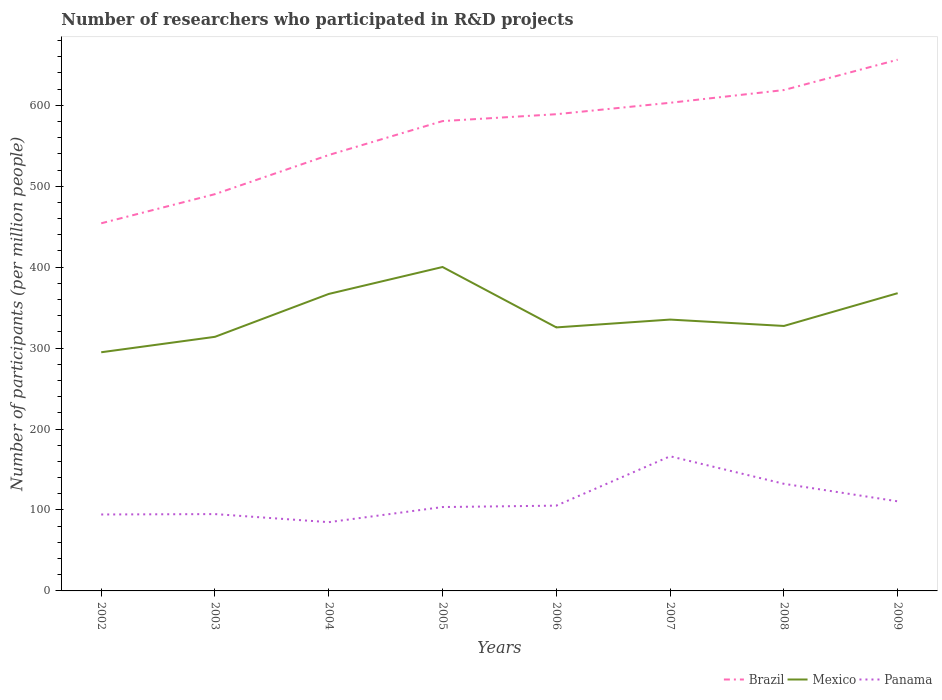How many different coloured lines are there?
Keep it short and to the point. 3. Across all years, what is the maximum number of researchers who participated in R&D projects in Mexico?
Offer a very short reply. 294.87. What is the total number of researchers who participated in R&D projects in Brazil in the graph?
Your answer should be compact. -8.49. What is the difference between the highest and the second highest number of researchers who participated in R&D projects in Mexico?
Offer a very short reply. 105.34. What is the difference between the highest and the lowest number of researchers who participated in R&D projects in Mexico?
Provide a short and direct response. 3. How many lines are there?
Ensure brevity in your answer.  3. How many years are there in the graph?
Keep it short and to the point. 8. What is the difference between two consecutive major ticks on the Y-axis?
Keep it short and to the point. 100. Does the graph contain any zero values?
Provide a succinct answer. No. What is the title of the graph?
Provide a short and direct response. Number of researchers who participated in R&D projects. What is the label or title of the X-axis?
Ensure brevity in your answer.  Years. What is the label or title of the Y-axis?
Your response must be concise. Number of participants (per million people). What is the Number of participants (per million people) of Brazil in 2002?
Provide a succinct answer. 454.21. What is the Number of participants (per million people) of Mexico in 2002?
Provide a succinct answer. 294.87. What is the Number of participants (per million people) of Panama in 2002?
Keep it short and to the point. 94.44. What is the Number of participants (per million people) in Brazil in 2003?
Your response must be concise. 490.22. What is the Number of participants (per million people) of Mexico in 2003?
Provide a short and direct response. 313.95. What is the Number of participants (per million people) of Panama in 2003?
Your answer should be very brief. 94.93. What is the Number of participants (per million people) of Brazil in 2004?
Your response must be concise. 538.58. What is the Number of participants (per million people) in Mexico in 2004?
Your answer should be very brief. 366.94. What is the Number of participants (per million people) in Panama in 2004?
Keep it short and to the point. 84.95. What is the Number of participants (per million people) of Brazil in 2005?
Your response must be concise. 580.49. What is the Number of participants (per million people) of Mexico in 2005?
Provide a short and direct response. 400.21. What is the Number of participants (per million people) in Panama in 2005?
Provide a succinct answer. 103.64. What is the Number of participants (per million people) in Brazil in 2006?
Offer a terse response. 588.98. What is the Number of participants (per million people) in Mexico in 2006?
Make the answer very short. 325.58. What is the Number of participants (per million people) in Panama in 2006?
Provide a short and direct response. 105.37. What is the Number of participants (per million people) in Brazil in 2007?
Keep it short and to the point. 603.11. What is the Number of participants (per million people) in Mexico in 2007?
Your answer should be very brief. 335.25. What is the Number of participants (per million people) of Panama in 2007?
Provide a succinct answer. 166.36. What is the Number of participants (per million people) of Brazil in 2008?
Your response must be concise. 618.83. What is the Number of participants (per million people) of Mexico in 2008?
Provide a short and direct response. 327.37. What is the Number of participants (per million people) in Panama in 2008?
Provide a succinct answer. 132.34. What is the Number of participants (per million people) in Brazil in 2009?
Offer a very short reply. 656.34. What is the Number of participants (per million people) of Mexico in 2009?
Your answer should be very brief. 367.87. What is the Number of participants (per million people) in Panama in 2009?
Provide a short and direct response. 110.69. Across all years, what is the maximum Number of participants (per million people) in Brazil?
Offer a terse response. 656.34. Across all years, what is the maximum Number of participants (per million people) in Mexico?
Ensure brevity in your answer.  400.21. Across all years, what is the maximum Number of participants (per million people) of Panama?
Offer a very short reply. 166.36. Across all years, what is the minimum Number of participants (per million people) of Brazil?
Your answer should be very brief. 454.21. Across all years, what is the minimum Number of participants (per million people) of Mexico?
Ensure brevity in your answer.  294.87. Across all years, what is the minimum Number of participants (per million people) of Panama?
Give a very brief answer. 84.95. What is the total Number of participants (per million people) in Brazil in the graph?
Your answer should be compact. 4530.75. What is the total Number of participants (per million people) in Mexico in the graph?
Your response must be concise. 2732.04. What is the total Number of participants (per million people) in Panama in the graph?
Provide a short and direct response. 892.71. What is the difference between the Number of participants (per million people) in Brazil in 2002 and that in 2003?
Offer a terse response. -36.01. What is the difference between the Number of participants (per million people) in Mexico in 2002 and that in 2003?
Make the answer very short. -19.08. What is the difference between the Number of participants (per million people) in Panama in 2002 and that in 2003?
Offer a very short reply. -0.48. What is the difference between the Number of participants (per million people) in Brazil in 2002 and that in 2004?
Your answer should be compact. -84.37. What is the difference between the Number of participants (per million people) in Mexico in 2002 and that in 2004?
Keep it short and to the point. -72.07. What is the difference between the Number of participants (per million people) of Panama in 2002 and that in 2004?
Provide a short and direct response. 9.49. What is the difference between the Number of participants (per million people) of Brazil in 2002 and that in 2005?
Your answer should be very brief. -126.28. What is the difference between the Number of participants (per million people) of Mexico in 2002 and that in 2005?
Offer a terse response. -105.34. What is the difference between the Number of participants (per million people) of Panama in 2002 and that in 2005?
Your answer should be compact. -9.19. What is the difference between the Number of participants (per million people) of Brazil in 2002 and that in 2006?
Ensure brevity in your answer.  -134.77. What is the difference between the Number of participants (per million people) of Mexico in 2002 and that in 2006?
Your answer should be very brief. -30.71. What is the difference between the Number of participants (per million people) in Panama in 2002 and that in 2006?
Your answer should be compact. -10.93. What is the difference between the Number of participants (per million people) of Brazil in 2002 and that in 2007?
Your answer should be very brief. -148.9. What is the difference between the Number of participants (per million people) of Mexico in 2002 and that in 2007?
Your response must be concise. -40.38. What is the difference between the Number of participants (per million people) of Panama in 2002 and that in 2007?
Ensure brevity in your answer.  -71.91. What is the difference between the Number of participants (per million people) in Brazil in 2002 and that in 2008?
Give a very brief answer. -164.62. What is the difference between the Number of participants (per million people) of Mexico in 2002 and that in 2008?
Provide a succinct answer. -32.5. What is the difference between the Number of participants (per million people) in Panama in 2002 and that in 2008?
Offer a very short reply. -37.89. What is the difference between the Number of participants (per million people) of Brazil in 2002 and that in 2009?
Ensure brevity in your answer.  -202.12. What is the difference between the Number of participants (per million people) of Mexico in 2002 and that in 2009?
Provide a succinct answer. -73. What is the difference between the Number of participants (per million people) in Panama in 2002 and that in 2009?
Keep it short and to the point. -16.25. What is the difference between the Number of participants (per million people) in Brazil in 2003 and that in 2004?
Keep it short and to the point. -48.36. What is the difference between the Number of participants (per million people) in Mexico in 2003 and that in 2004?
Provide a succinct answer. -52.99. What is the difference between the Number of participants (per million people) of Panama in 2003 and that in 2004?
Make the answer very short. 9.97. What is the difference between the Number of participants (per million people) in Brazil in 2003 and that in 2005?
Offer a very short reply. -90.27. What is the difference between the Number of participants (per million people) in Mexico in 2003 and that in 2005?
Provide a short and direct response. -86.25. What is the difference between the Number of participants (per million people) in Panama in 2003 and that in 2005?
Your answer should be compact. -8.71. What is the difference between the Number of participants (per million people) in Brazil in 2003 and that in 2006?
Offer a terse response. -98.76. What is the difference between the Number of participants (per million people) of Mexico in 2003 and that in 2006?
Your answer should be very brief. -11.63. What is the difference between the Number of participants (per million people) in Panama in 2003 and that in 2006?
Offer a terse response. -10.44. What is the difference between the Number of participants (per million people) in Brazil in 2003 and that in 2007?
Give a very brief answer. -112.89. What is the difference between the Number of participants (per million people) of Mexico in 2003 and that in 2007?
Provide a short and direct response. -21.3. What is the difference between the Number of participants (per million people) in Panama in 2003 and that in 2007?
Keep it short and to the point. -71.43. What is the difference between the Number of participants (per million people) in Brazil in 2003 and that in 2008?
Give a very brief answer. -128.61. What is the difference between the Number of participants (per million people) in Mexico in 2003 and that in 2008?
Ensure brevity in your answer.  -13.42. What is the difference between the Number of participants (per million people) of Panama in 2003 and that in 2008?
Offer a terse response. -37.41. What is the difference between the Number of participants (per million people) in Brazil in 2003 and that in 2009?
Offer a terse response. -166.11. What is the difference between the Number of participants (per million people) of Mexico in 2003 and that in 2009?
Provide a short and direct response. -53.91. What is the difference between the Number of participants (per million people) in Panama in 2003 and that in 2009?
Give a very brief answer. -15.77. What is the difference between the Number of participants (per million people) in Brazil in 2004 and that in 2005?
Keep it short and to the point. -41.91. What is the difference between the Number of participants (per million people) of Mexico in 2004 and that in 2005?
Provide a succinct answer. -33.27. What is the difference between the Number of participants (per million people) in Panama in 2004 and that in 2005?
Your response must be concise. -18.68. What is the difference between the Number of participants (per million people) in Brazil in 2004 and that in 2006?
Your response must be concise. -50.41. What is the difference between the Number of participants (per million people) in Mexico in 2004 and that in 2006?
Make the answer very short. 41.36. What is the difference between the Number of participants (per million people) of Panama in 2004 and that in 2006?
Offer a terse response. -20.42. What is the difference between the Number of participants (per million people) in Brazil in 2004 and that in 2007?
Give a very brief answer. -64.53. What is the difference between the Number of participants (per million people) of Mexico in 2004 and that in 2007?
Give a very brief answer. 31.69. What is the difference between the Number of participants (per million people) of Panama in 2004 and that in 2007?
Keep it short and to the point. -81.4. What is the difference between the Number of participants (per million people) of Brazil in 2004 and that in 2008?
Your response must be concise. -80.25. What is the difference between the Number of participants (per million people) in Mexico in 2004 and that in 2008?
Give a very brief answer. 39.57. What is the difference between the Number of participants (per million people) of Panama in 2004 and that in 2008?
Keep it short and to the point. -47.38. What is the difference between the Number of participants (per million people) of Brazil in 2004 and that in 2009?
Ensure brevity in your answer.  -117.76. What is the difference between the Number of participants (per million people) in Mexico in 2004 and that in 2009?
Provide a short and direct response. -0.93. What is the difference between the Number of participants (per million people) of Panama in 2004 and that in 2009?
Provide a succinct answer. -25.74. What is the difference between the Number of participants (per million people) in Brazil in 2005 and that in 2006?
Provide a short and direct response. -8.49. What is the difference between the Number of participants (per million people) of Mexico in 2005 and that in 2006?
Give a very brief answer. 74.63. What is the difference between the Number of participants (per million people) in Panama in 2005 and that in 2006?
Your answer should be compact. -1.73. What is the difference between the Number of participants (per million people) in Brazil in 2005 and that in 2007?
Offer a terse response. -22.62. What is the difference between the Number of participants (per million people) of Mexico in 2005 and that in 2007?
Provide a short and direct response. 64.96. What is the difference between the Number of participants (per million people) of Panama in 2005 and that in 2007?
Give a very brief answer. -62.72. What is the difference between the Number of participants (per million people) of Brazil in 2005 and that in 2008?
Your response must be concise. -38.34. What is the difference between the Number of participants (per million people) of Mexico in 2005 and that in 2008?
Make the answer very short. 72.84. What is the difference between the Number of participants (per million people) in Panama in 2005 and that in 2008?
Offer a very short reply. -28.7. What is the difference between the Number of participants (per million people) in Brazil in 2005 and that in 2009?
Your response must be concise. -75.85. What is the difference between the Number of participants (per million people) of Mexico in 2005 and that in 2009?
Offer a very short reply. 32.34. What is the difference between the Number of participants (per million people) in Panama in 2005 and that in 2009?
Your response must be concise. -7.06. What is the difference between the Number of participants (per million people) of Brazil in 2006 and that in 2007?
Keep it short and to the point. -14.13. What is the difference between the Number of participants (per million people) of Mexico in 2006 and that in 2007?
Offer a very short reply. -9.67. What is the difference between the Number of participants (per million people) in Panama in 2006 and that in 2007?
Offer a very short reply. -60.99. What is the difference between the Number of participants (per million people) in Brazil in 2006 and that in 2008?
Your answer should be compact. -29.85. What is the difference between the Number of participants (per million people) in Mexico in 2006 and that in 2008?
Offer a terse response. -1.79. What is the difference between the Number of participants (per million people) of Panama in 2006 and that in 2008?
Offer a terse response. -26.97. What is the difference between the Number of participants (per million people) in Brazil in 2006 and that in 2009?
Make the answer very short. -67.35. What is the difference between the Number of participants (per million people) of Mexico in 2006 and that in 2009?
Provide a short and direct response. -42.29. What is the difference between the Number of participants (per million people) in Panama in 2006 and that in 2009?
Offer a terse response. -5.32. What is the difference between the Number of participants (per million people) in Brazil in 2007 and that in 2008?
Make the answer very short. -15.72. What is the difference between the Number of participants (per million people) of Mexico in 2007 and that in 2008?
Offer a very short reply. 7.88. What is the difference between the Number of participants (per million people) of Panama in 2007 and that in 2008?
Provide a short and direct response. 34.02. What is the difference between the Number of participants (per million people) of Brazil in 2007 and that in 2009?
Give a very brief answer. -53.23. What is the difference between the Number of participants (per million people) in Mexico in 2007 and that in 2009?
Your response must be concise. -32.62. What is the difference between the Number of participants (per million people) of Panama in 2007 and that in 2009?
Offer a terse response. 55.66. What is the difference between the Number of participants (per million people) in Brazil in 2008 and that in 2009?
Provide a succinct answer. -37.51. What is the difference between the Number of participants (per million people) of Mexico in 2008 and that in 2009?
Offer a very short reply. -40.49. What is the difference between the Number of participants (per million people) of Panama in 2008 and that in 2009?
Provide a succinct answer. 21.64. What is the difference between the Number of participants (per million people) of Brazil in 2002 and the Number of participants (per million people) of Mexico in 2003?
Ensure brevity in your answer.  140.26. What is the difference between the Number of participants (per million people) in Brazil in 2002 and the Number of participants (per million people) in Panama in 2003?
Offer a very short reply. 359.29. What is the difference between the Number of participants (per million people) in Mexico in 2002 and the Number of participants (per million people) in Panama in 2003?
Offer a very short reply. 199.95. What is the difference between the Number of participants (per million people) of Brazil in 2002 and the Number of participants (per million people) of Mexico in 2004?
Give a very brief answer. 87.27. What is the difference between the Number of participants (per million people) of Brazil in 2002 and the Number of participants (per million people) of Panama in 2004?
Your answer should be very brief. 369.26. What is the difference between the Number of participants (per million people) of Mexico in 2002 and the Number of participants (per million people) of Panama in 2004?
Make the answer very short. 209.92. What is the difference between the Number of participants (per million people) in Brazil in 2002 and the Number of participants (per million people) in Mexico in 2005?
Provide a short and direct response. 54. What is the difference between the Number of participants (per million people) of Brazil in 2002 and the Number of participants (per million people) of Panama in 2005?
Your response must be concise. 350.58. What is the difference between the Number of participants (per million people) in Mexico in 2002 and the Number of participants (per million people) in Panama in 2005?
Make the answer very short. 191.23. What is the difference between the Number of participants (per million people) in Brazil in 2002 and the Number of participants (per million people) in Mexico in 2006?
Your answer should be compact. 128.63. What is the difference between the Number of participants (per million people) of Brazil in 2002 and the Number of participants (per million people) of Panama in 2006?
Provide a short and direct response. 348.84. What is the difference between the Number of participants (per million people) of Mexico in 2002 and the Number of participants (per million people) of Panama in 2006?
Your answer should be very brief. 189.5. What is the difference between the Number of participants (per million people) in Brazil in 2002 and the Number of participants (per million people) in Mexico in 2007?
Offer a very short reply. 118.96. What is the difference between the Number of participants (per million people) in Brazil in 2002 and the Number of participants (per million people) in Panama in 2007?
Make the answer very short. 287.86. What is the difference between the Number of participants (per million people) of Mexico in 2002 and the Number of participants (per million people) of Panama in 2007?
Your answer should be very brief. 128.51. What is the difference between the Number of participants (per million people) in Brazil in 2002 and the Number of participants (per million people) in Mexico in 2008?
Give a very brief answer. 126.84. What is the difference between the Number of participants (per million people) in Brazil in 2002 and the Number of participants (per million people) in Panama in 2008?
Your answer should be very brief. 321.88. What is the difference between the Number of participants (per million people) in Mexico in 2002 and the Number of participants (per million people) in Panama in 2008?
Provide a succinct answer. 162.54. What is the difference between the Number of participants (per million people) in Brazil in 2002 and the Number of participants (per million people) in Mexico in 2009?
Your answer should be very brief. 86.34. What is the difference between the Number of participants (per million people) in Brazil in 2002 and the Number of participants (per million people) in Panama in 2009?
Make the answer very short. 343.52. What is the difference between the Number of participants (per million people) in Mexico in 2002 and the Number of participants (per million people) in Panama in 2009?
Make the answer very short. 184.18. What is the difference between the Number of participants (per million people) of Brazil in 2003 and the Number of participants (per million people) of Mexico in 2004?
Make the answer very short. 123.28. What is the difference between the Number of participants (per million people) in Brazil in 2003 and the Number of participants (per million people) in Panama in 2004?
Your response must be concise. 405.27. What is the difference between the Number of participants (per million people) in Mexico in 2003 and the Number of participants (per million people) in Panama in 2004?
Provide a short and direct response. 229. What is the difference between the Number of participants (per million people) of Brazil in 2003 and the Number of participants (per million people) of Mexico in 2005?
Provide a short and direct response. 90.01. What is the difference between the Number of participants (per million people) of Brazil in 2003 and the Number of participants (per million people) of Panama in 2005?
Provide a short and direct response. 386.58. What is the difference between the Number of participants (per million people) of Mexico in 2003 and the Number of participants (per million people) of Panama in 2005?
Your answer should be very brief. 210.32. What is the difference between the Number of participants (per million people) of Brazil in 2003 and the Number of participants (per million people) of Mexico in 2006?
Provide a short and direct response. 164.64. What is the difference between the Number of participants (per million people) of Brazil in 2003 and the Number of participants (per million people) of Panama in 2006?
Make the answer very short. 384.85. What is the difference between the Number of participants (per million people) of Mexico in 2003 and the Number of participants (per million people) of Panama in 2006?
Make the answer very short. 208.58. What is the difference between the Number of participants (per million people) of Brazil in 2003 and the Number of participants (per million people) of Mexico in 2007?
Keep it short and to the point. 154.97. What is the difference between the Number of participants (per million people) of Brazil in 2003 and the Number of participants (per million people) of Panama in 2007?
Provide a succinct answer. 323.86. What is the difference between the Number of participants (per million people) in Mexico in 2003 and the Number of participants (per million people) in Panama in 2007?
Make the answer very short. 147.6. What is the difference between the Number of participants (per million people) of Brazil in 2003 and the Number of participants (per million people) of Mexico in 2008?
Offer a very short reply. 162.85. What is the difference between the Number of participants (per million people) in Brazil in 2003 and the Number of participants (per million people) in Panama in 2008?
Your answer should be compact. 357.89. What is the difference between the Number of participants (per million people) in Mexico in 2003 and the Number of participants (per million people) in Panama in 2008?
Your answer should be compact. 181.62. What is the difference between the Number of participants (per million people) of Brazil in 2003 and the Number of participants (per million people) of Mexico in 2009?
Keep it short and to the point. 122.35. What is the difference between the Number of participants (per million people) in Brazil in 2003 and the Number of participants (per million people) in Panama in 2009?
Keep it short and to the point. 379.53. What is the difference between the Number of participants (per million people) in Mexico in 2003 and the Number of participants (per million people) in Panama in 2009?
Your answer should be very brief. 203.26. What is the difference between the Number of participants (per million people) in Brazil in 2004 and the Number of participants (per million people) in Mexico in 2005?
Offer a very short reply. 138.37. What is the difference between the Number of participants (per million people) in Brazil in 2004 and the Number of participants (per million people) in Panama in 2005?
Your answer should be very brief. 434.94. What is the difference between the Number of participants (per million people) of Mexico in 2004 and the Number of participants (per million people) of Panama in 2005?
Offer a very short reply. 263.3. What is the difference between the Number of participants (per million people) in Brazil in 2004 and the Number of participants (per million people) in Mexico in 2006?
Keep it short and to the point. 213. What is the difference between the Number of participants (per million people) in Brazil in 2004 and the Number of participants (per million people) in Panama in 2006?
Keep it short and to the point. 433.21. What is the difference between the Number of participants (per million people) of Mexico in 2004 and the Number of participants (per million people) of Panama in 2006?
Make the answer very short. 261.57. What is the difference between the Number of participants (per million people) in Brazil in 2004 and the Number of participants (per million people) in Mexico in 2007?
Ensure brevity in your answer.  203.33. What is the difference between the Number of participants (per million people) in Brazil in 2004 and the Number of participants (per million people) in Panama in 2007?
Offer a very short reply. 372.22. What is the difference between the Number of participants (per million people) of Mexico in 2004 and the Number of participants (per million people) of Panama in 2007?
Your response must be concise. 200.58. What is the difference between the Number of participants (per million people) of Brazil in 2004 and the Number of participants (per million people) of Mexico in 2008?
Your answer should be very brief. 211.2. What is the difference between the Number of participants (per million people) of Brazil in 2004 and the Number of participants (per million people) of Panama in 2008?
Your answer should be compact. 406.24. What is the difference between the Number of participants (per million people) of Mexico in 2004 and the Number of participants (per million people) of Panama in 2008?
Keep it short and to the point. 234.6. What is the difference between the Number of participants (per million people) of Brazil in 2004 and the Number of participants (per million people) of Mexico in 2009?
Make the answer very short. 170.71. What is the difference between the Number of participants (per million people) of Brazil in 2004 and the Number of participants (per million people) of Panama in 2009?
Make the answer very short. 427.88. What is the difference between the Number of participants (per million people) in Mexico in 2004 and the Number of participants (per million people) in Panama in 2009?
Provide a succinct answer. 256.25. What is the difference between the Number of participants (per million people) in Brazil in 2005 and the Number of participants (per million people) in Mexico in 2006?
Offer a very short reply. 254.91. What is the difference between the Number of participants (per million people) in Brazil in 2005 and the Number of participants (per million people) in Panama in 2006?
Offer a terse response. 475.12. What is the difference between the Number of participants (per million people) of Mexico in 2005 and the Number of participants (per million people) of Panama in 2006?
Your answer should be very brief. 294.84. What is the difference between the Number of participants (per million people) of Brazil in 2005 and the Number of participants (per million people) of Mexico in 2007?
Ensure brevity in your answer.  245.24. What is the difference between the Number of participants (per million people) in Brazil in 2005 and the Number of participants (per million people) in Panama in 2007?
Offer a terse response. 414.13. What is the difference between the Number of participants (per million people) of Mexico in 2005 and the Number of participants (per million people) of Panama in 2007?
Your response must be concise. 233.85. What is the difference between the Number of participants (per million people) in Brazil in 2005 and the Number of participants (per million people) in Mexico in 2008?
Keep it short and to the point. 253.12. What is the difference between the Number of participants (per million people) in Brazil in 2005 and the Number of participants (per million people) in Panama in 2008?
Your answer should be compact. 448.15. What is the difference between the Number of participants (per million people) of Mexico in 2005 and the Number of participants (per million people) of Panama in 2008?
Provide a succinct answer. 267.87. What is the difference between the Number of participants (per million people) in Brazil in 2005 and the Number of participants (per million people) in Mexico in 2009?
Your answer should be compact. 212.62. What is the difference between the Number of participants (per million people) in Brazil in 2005 and the Number of participants (per million people) in Panama in 2009?
Give a very brief answer. 469.8. What is the difference between the Number of participants (per million people) in Mexico in 2005 and the Number of participants (per million people) in Panama in 2009?
Offer a terse response. 289.52. What is the difference between the Number of participants (per million people) in Brazil in 2006 and the Number of participants (per million people) in Mexico in 2007?
Provide a succinct answer. 253.73. What is the difference between the Number of participants (per million people) of Brazil in 2006 and the Number of participants (per million people) of Panama in 2007?
Offer a terse response. 422.63. What is the difference between the Number of participants (per million people) of Mexico in 2006 and the Number of participants (per million people) of Panama in 2007?
Keep it short and to the point. 159.22. What is the difference between the Number of participants (per million people) in Brazil in 2006 and the Number of participants (per million people) in Mexico in 2008?
Your answer should be compact. 261.61. What is the difference between the Number of participants (per million people) in Brazil in 2006 and the Number of participants (per million people) in Panama in 2008?
Ensure brevity in your answer.  456.65. What is the difference between the Number of participants (per million people) of Mexico in 2006 and the Number of participants (per million people) of Panama in 2008?
Provide a succinct answer. 193.24. What is the difference between the Number of participants (per million people) in Brazil in 2006 and the Number of participants (per million people) in Mexico in 2009?
Ensure brevity in your answer.  221.12. What is the difference between the Number of participants (per million people) in Brazil in 2006 and the Number of participants (per million people) in Panama in 2009?
Your answer should be very brief. 478.29. What is the difference between the Number of participants (per million people) in Mexico in 2006 and the Number of participants (per million people) in Panama in 2009?
Your response must be concise. 214.89. What is the difference between the Number of participants (per million people) in Brazil in 2007 and the Number of participants (per million people) in Mexico in 2008?
Give a very brief answer. 275.74. What is the difference between the Number of participants (per million people) in Brazil in 2007 and the Number of participants (per million people) in Panama in 2008?
Make the answer very short. 470.77. What is the difference between the Number of participants (per million people) in Mexico in 2007 and the Number of participants (per million people) in Panama in 2008?
Your response must be concise. 202.91. What is the difference between the Number of participants (per million people) in Brazil in 2007 and the Number of participants (per million people) in Mexico in 2009?
Offer a terse response. 235.24. What is the difference between the Number of participants (per million people) in Brazil in 2007 and the Number of participants (per million people) in Panama in 2009?
Your answer should be very brief. 492.42. What is the difference between the Number of participants (per million people) in Mexico in 2007 and the Number of participants (per million people) in Panama in 2009?
Your answer should be very brief. 224.56. What is the difference between the Number of participants (per million people) in Brazil in 2008 and the Number of participants (per million people) in Mexico in 2009?
Your answer should be very brief. 250.96. What is the difference between the Number of participants (per million people) in Brazil in 2008 and the Number of participants (per million people) in Panama in 2009?
Offer a terse response. 508.14. What is the difference between the Number of participants (per million people) of Mexico in 2008 and the Number of participants (per million people) of Panama in 2009?
Give a very brief answer. 216.68. What is the average Number of participants (per million people) in Brazil per year?
Make the answer very short. 566.34. What is the average Number of participants (per million people) of Mexico per year?
Give a very brief answer. 341.51. What is the average Number of participants (per million people) in Panama per year?
Provide a succinct answer. 111.59. In the year 2002, what is the difference between the Number of participants (per million people) of Brazil and Number of participants (per million people) of Mexico?
Offer a terse response. 159.34. In the year 2002, what is the difference between the Number of participants (per million people) in Brazil and Number of participants (per million people) in Panama?
Your answer should be compact. 359.77. In the year 2002, what is the difference between the Number of participants (per million people) of Mexico and Number of participants (per million people) of Panama?
Make the answer very short. 200.43. In the year 2003, what is the difference between the Number of participants (per million people) in Brazil and Number of participants (per million people) in Mexico?
Give a very brief answer. 176.27. In the year 2003, what is the difference between the Number of participants (per million people) in Brazil and Number of participants (per million people) in Panama?
Offer a very short reply. 395.3. In the year 2003, what is the difference between the Number of participants (per million people) in Mexico and Number of participants (per million people) in Panama?
Offer a very short reply. 219.03. In the year 2004, what is the difference between the Number of participants (per million people) of Brazil and Number of participants (per million people) of Mexico?
Give a very brief answer. 171.64. In the year 2004, what is the difference between the Number of participants (per million people) in Brazil and Number of participants (per million people) in Panama?
Your response must be concise. 453.62. In the year 2004, what is the difference between the Number of participants (per million people) of Mexico and Number of participants (per million people) of Panama?
Your response must be concise. 281.99. In the year 2005, what is the difference between the Number of participants (per million people) of Brazil and Number of participants (per million people) of Mexico?
Provide a succinct answer. 180.28. In the year 2005, what is the difference between the Number of participants (per million people) in Brazil and Number of participants (per million people) in Panama?
Give a very brief answer. 476.85. In the year 2005, what is the difference between the Number of participants (per million people) in Mexico and Number of participants (per million people) in Panama?
Keep it short and to the point. 296.57. In the year 2006, what is the difference between the Number of participants (per million people) of Brazil and Number of participants (per million people) of Mexico?
Your answer should be compact. 263.4. In the year 2006, what is the difference between the Number of participants (per million people) in Brazil and Number of participants (per million people) in Panama?
Give a very brief answer. 483.61. In the year 2006, what is the difference between the Number of participants (per million people) in Mexico and Number of participants (per million people) in Panama?
Your answer should be compact. 220.21. In the year 2007, what is the difference between the Number of participants (per million people) in Brazil and Number of participants (per million people) in Mexico?
Keep it short and to the point. 267.86. In the year 2007, what is the difference between the Number of participants (per million people) of Brazil and Number of participants (per million people) of Panama?
Provide a short and direct response. 436.75. In the year 2007, what is the difference between the Number of participants (per million people) in Mexico and Number of participants (per million people) in Panama?
Your response must be concise. 168.89. In the year 2008, what is the difference between the Number of participants (per million people) of Brazil and Number of participants (per million people) of Mexico?
Provide a short and direct response. 291.46. In the year 2008, what is the difference between the Number of participants (per million people) in Brazil and Number of participants (per million people) in Panama?
Your answer should be very brief. 486.49. In the year 2008, what is the difference between the Number of participants (per million people) in Mexico and Number of participants (per million people) in Panama?
Provide a succinct answer. 195.04. In the year 2009, what is the difference between the Number of participants (per million people) of Brazil and Number of participants (per million people) of Mexico?
Offer a terse response. 288.47. In the year 2009, what is the difference between the Number of participants (per million people) of Brazil and Number of participants (per million people) of Panama?
Keep it short and to the point. 545.64. In the year 2009, what is the difference between the Number of participants (per million people) in Mexico and Number of participants (per million people) in Panama?
Your answer should be compact. 257.17. What is the ratio of the Number of participants (per million people) in Brazil in 2002 to that in 2003?
Your answer should be very brief. 0.93. What is the ratio of the Number of participants (per million people) in Mexico in 2002 to that in 2003?
Make the answer very short. 0.94. What is the ratio of the Number of participants (per million people) of Brazil in 2002 to that in 2004?
Your response must be concise. 0.84. What is the ratio of the Number of participants (per million people) in Mexico in 2002 to that in 2004?
Ensure brevity in your answer.  0.8. What is the ratio of the Number of participants (per million people) in Panama in 2002 to that in 2004?
Offer a terse response. 1.11. What is the ratio of the Number of participants (per million people) of Brazil in 2002 to that in 2005?
Offer a terse response. 0.78. What is the ratio of the Number of participants (per million people) of Mexico in 2002 to that in 2005?
Make the answer very short. 0.74. What is the ratio of the Number of participants (per million people) in Panama in 2002 to that in 2005?
Your response must be concise. 0.91. What is the ratio of the Number of participants (per million people) in Brazil in 2002 to that in 2006?
Your response must be concise. 0.77. What is the ratio of the Number of participants (per million people) in Mexico in 2002 to that in 2006?
Offer a very short reply. 0.91. What is the ratio of the Number of participants (per million people) in Panama in 2002 to that in 2006?
Keep it short and to the point. 0.9. What is the ratio of the Number of participants (per million people) in Brazil in 2002 to that in 2007?
Provide a succinct answer. 0.75. What is the ratio of the Number of participants (per million people) in Mexico in 2002 to that in 2007?
Provide a short and direct response. 0.88. What is the ratio of the Number of participants (per million people) in Panama in 2002 to that in 2007?
Keep it short and to the point. 0.57. What is the ratio of the Number of participants (per million people) in Brazil in 2002 to that in 2008?
Keep it short and to the point. 0.73. What is the ratio of the Number of participants (per million people) in Mexico in 2002 to that in 2008?
Your answer should be compact. 0.9. What is the ratio of the Number of participants (per million people) of Panama in 2002 to that in 2008?
Ensure brevity in your answer.  0.71. What is the ratio of the Number of participants (per million people) of Brazil in 2002 to that in 2009?
Your answer should be compact. 0.69. What is the ratio of the Number of participants (per million people) of Mexico in 2002 to that in 2009?
Your answer should be very brief. 0.8. What is the ratio of the Number of participants (per million people) of Panama in 2002 to that in 2009?
Ensure brevity in your answer.  0.85. What is the ratio of the Number of participants (per million people) of Brazil in 2003 to that in 2004?
Keep it short and to the point. 0.91. What is the ratio of the Number of participants (per million people) of Mexico in 2003 to that in 2004?
Offer a very short reply. 0.86. What is the ratio of the Number of participants (per million people) in Panama in 2003 to that in 2004?
Offer a terse response. 1.12. What is the ratio of the Number of participants (per million people) of Brazil in 2003 to that in 2005?
Ensure brevity in your answer.  0.84. What is the ratio of the Number of participants (per million people) of Mexico in 2003 to that in 2005?
Provide a succinct answer. 0.78. What is the ratio of the Number of participants (per million people) in Panama in 2003 to that in 2005?
Provide a short and direct response. 0.92. What is the ratio of the Number of participants (per million people) in Brazil in 2003 to that in 2006?
Your response must be concise. 0.83. What is the ratio of the Number of participants (per million people) of Mexico in 2003 to that in 2006?
Your answer should be very brief. 0.96. What is the ratio of the Number of participants (per million people) in Panama in 2003 to that in 2006?
Keep it short and to the point. 0.9. What is the ratio of the Number of participants (per million people) of Brazil in 2003 to that in 2007?
Provide a short and direct response. 0.81. What is the ratio of the Number of participants (per million people) of Mexico in 2003 to that in 2007?
Ensure brevity in your answer.  0.94. What is the ratio of the Number of participants (per million people) of Panama in 2003 to that in 2007?
Your answer should be compact. 0.57. What is the ratio of the Number of participants (per million people) of Brazil in 2003 to that in 2008?
Your answer should be very brief. 0.79. What is the ratio of the Number of participants (per million people) of Panama in 2003 to that in 2008?
Keep it short and to the point. 0.72. What is the ratio of the Number of participants (per million people) in Brazil in 2003 to that in 2009?
Your response must be concise. 0.75. What is the ratio of the Number of participants (per million people) of Mexico in 2003 to that in 2009?
Provide a succinct answer. 0.85. What is the ratio of the Number of participants (per million people) in Panama in 2003 to that in 2009?
Provide a short and direct response. 0.86. What is the ratio of the Number of participants (per million people) in Brazil in 2004 to that in 2005?
Provide a succinct answer. 0.93. What is the ratio of the Number of participants (per million people) in Mexico in 2004 to that in 2005?
Make the answer very short. 0.92. What is the ratio of the Number of participants (per million people) in Panama in 2004 to that in 2005?
Provide a succinct answer. 0.82. What is the ratio of the Number of participants (per million people) in Brazil in 2004 to that in 2006?
Ensure brevity in your answer.  0.91. What is the ratio of the Number of participants (per million people) in Mexico in 2004 to that in 2006?
Provide a succinct answer. 1.13. What is the ratio of the Number of participants (per million people) of Panama in 2004 to that in 2006?
Provide a short and direct response. 0.81. What is the ratio of the Number of participants (per million people) in Brazil in 2004 to that in 2007?
Provide a succinct answer. 0.89. What is the ratio of the Number of participants (per million people) in Mexico in 2004 to that in 2007?
Keep it short and to the point. 1.09. What is the ratio of the Number of participants (per million people) in Panama in 2004 to that in 2007?
Provide a short and direct response. 0.51. What is the ratio of the Number of participants (per million people) in Brazil in 2004 to that in 2008?
Your response must be concise. 0.87. What is the ratio of the Number of participants (per million people) of Mexico in 2004 to that in 2008?
Provide a succinct answer. 1.12. What is the ratio of the Number of participants (per million people) in Panama in 2004 to that in 2008?
Offer a very short reply. 0.64. What is the ratio of the Number of participants (per million people) of Brazil in 2004 to that in 2009?
Keep it short and to the point. 0.82. What is the ratio of the Number of participants (per million people) of Panama in 2004 to that in 2009?
Make the answer very short. 0.77. What is the ratio of the Number of participants (per million people) of Brazil in 2005 to that in 2006?
Ensure brevity in your answer.  0.99. What is the ratio of the Number of participants (per million people) in Mexico in 2005 to that in 2006?
Your answer should be compact. 1.23. What is the ratio of the Number of participants (per million people) in Panama in 2005 to that in 2006?
Provide a short and direct response. 0.98. What is the ratio of the Number of participants (per million people) in Brazil in 2005 to that in 2007?
Provide a succinct answer. 0.96. What is the ratio of the Number of participants (per million people) in Mexico in 2005 to that in 2007?
Offer a terse response. 1.19. What is the ratio of the Number of participants (per million people) in Panama in 2005 to that in 2007?
Make the answer very short. 0.62. What is the ratio of the Number of participants (per million people) of Brazil in 2005 to that in 2008?
Provide a succinct answer. 0.94. What is the ratio of the Number of participants (per million people) in Mexico in 2005 to that in 2008?
Your answer should be compact. 1.22. What is the ratio of the Number of participants (per million people) of Panama in 2005 to that in 2008?
Provide a succinct answer. 0.78. What is the ratio of the Number of participants (per million people) of Brazil in 2005 to that in 2009?
Ensure brevity in your answer.  0.88. What is the ratio of the Number of participants (per million people) in Mexico in 2005 to that in 2009?
Make the answer very short. 1.09. What is the ratio of the Number of participants (per million people) in Panama in 2005 to that in 2009?
Provide a succinct answer. 0.94. What is the ratio of the Number of participants (per million people) of Brazil in 2006 to that in 2007?
Provide a short and direct response. 0.98. What is the ratio of the Number of participants (per million people) of Mexico in 2006 to that in 2007?
Your answer should be very brief. 0.97. What is the ratio of the Number of participants (per million people) in Panama in 2006 to that in 2007?
Keep it short and to the point. 0.63. What is the ratio of the Number of participants (per million people) of Brazil in 2006 to that in 2008?
Provide a succinct answer. 0.95. What is the ratio of the Number of participants (per million people) in Mexico in 2006 to that in 2008?
Ensure brevity in your answer.  0.99. What is the ratio of the Number of participants (per million people) of Panama in 2006 to that in 2008?
Give a very brief answer. 0.8. What is the ratio of the Number of participants (per million people) of Brazil in 2006 to that in 2009?
Ensure brevity in your answer.  0.9. What is the ratio of the Number of participants (per million people) in Mexico in 2006 to that in 2009?
Provide a succinct answer. 0.89. What is the ratio of the Number of participants (per million people) in Panama in 2006 to that in 2009?
Provide a succinct answer. 0.95. What is the ratio of the Number of participants (per million people) in Brazil in 2007 to that in 2008?
Give a very brief answer. 0.97. What is the ratio of the Number of participants (per million people) of Mexico in 2007 to that in 2008?
Provide a short and direct response. 1.02. What is the ratio of the Number of participants (per million people) in Panama in 2007 to that in 2008?
Your answer should be very brief. 1.26. What is the ratio of the Number of participants (per million people) in Brazil in 2007 to that in 2009?
Offer a terse response. 0.92. What is the ratio of the Number of participants (per million people) in Mexico in 2007 to that in 2009?
Your answer should be compact. 0.91. What is the ratio of the Number of participants (per million people) in Panama in 2007 to that in 2009?
Your answer should be very brief. 1.5. What is the ratio of the Number of participants (per million people) of Brazil in 2008 to that in 2009?
Provide a short and direct response. 0.94. What is the ratio of the Number of participants (per million people) in Mexico in 2008 to that in 2009?
Give a very brief answer. 0.89. What is the ratio of the Number of participants (per million people) of Panama in 2008 to that in 2009?
Make the answer very short. 1.2. What is the difference between the highest and the second highest Number of participants (per million people) in Brazil?
Keep it short and to the point. 37.51. What is the difference between the highest and the second highest Number of participants (per million people) of Mexico?
Provide a succinct answer. 32.34. What is the difference between the highest and the second highest Number of participants (per million people) of Panama?
Make the answer very short. 34.02. What is the difference between the highest and the lowest Number of participants (per million people) of Brazil?
Provide a short and direct response. 202.12. What is the difference between the highest and the lowest Number of participants (per million people) of Mexico?
Offer a terse response. 105.34. What is the difference between the highest and the lowest Number of participants (per million people) of Panama?
Make the answer very short. 81.4. 